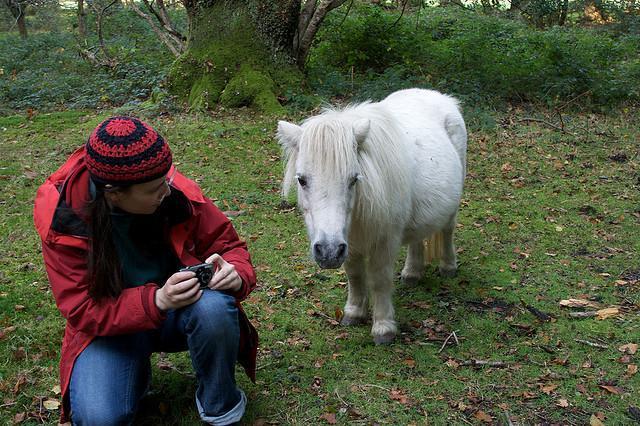Verify the accuracy of this image caption: "The horse is at the right side of the person.".
Answer yes or no. Yes. 